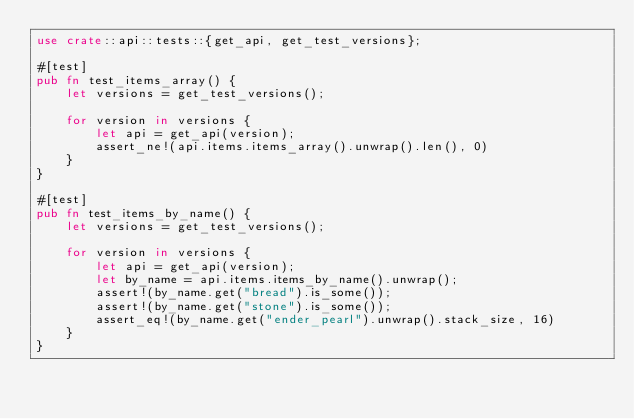Convert code to text. <code><loc_0><loc_0><loc_500><loc_500><_Rust_>use crate::api::tests::{get_api, get_test_versions};

#[test]
pub fn test_items_array() {
    let versions = get_test_versions();

    for version in versions {
        let api = get_api(version);
        assert_ne!(api.items.items_array().unwrap().len(), 0)
    }
}

#[test]
pub fn test_items_by_name() {
    let versions = get_test_versions();

    for version in versions {
        let api = get_api(version);
        let by_name = api.items.items_by_name().unwrap();
        assert!(by_name.get("bread").is_some());
        assert!(by_name.get("stone").is_some());
        assert_eq!(by_name.get("ender_pearl").unwrap().stack_size, 16)
    }
}
</code> 